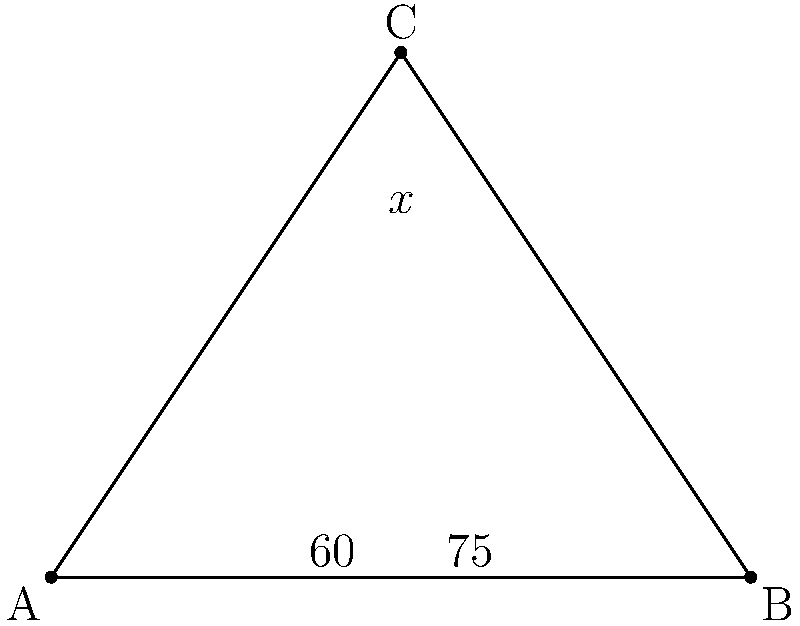In your kitchen, you notice two chef's knives intersecting on your cutting board. The blades form a triangle ABC as shown in the diagram. If the angle between one knife blade and the cutting board is $60°$, and the angle between the other knife blade and the cutting board is $75°$, what is the angle $x°$ between the two knife blades? Let's approach this step-by-step:

1) In a triangle, the sum of all interior angles is always $180°$.

2) We are given two angles of the triangle:
   - Angle BAC = $60°$
   - Angle ABC = $75°$

3) Let's call the angle we're looking for (angle ACB) as $x°$.

4) Using the triangle angle sum theorem:
   $60° + 75° + x° = 180°$

5) Simplifying:
   $135° + x° = 180°$

6) Subtracting both sides by $135°$:
   $x° = 180° - 135°$

7) Calculating:
   $x° = 45°$

Therefore, the angle between the two knife blades is $45°$.
Answer: $45°$ 